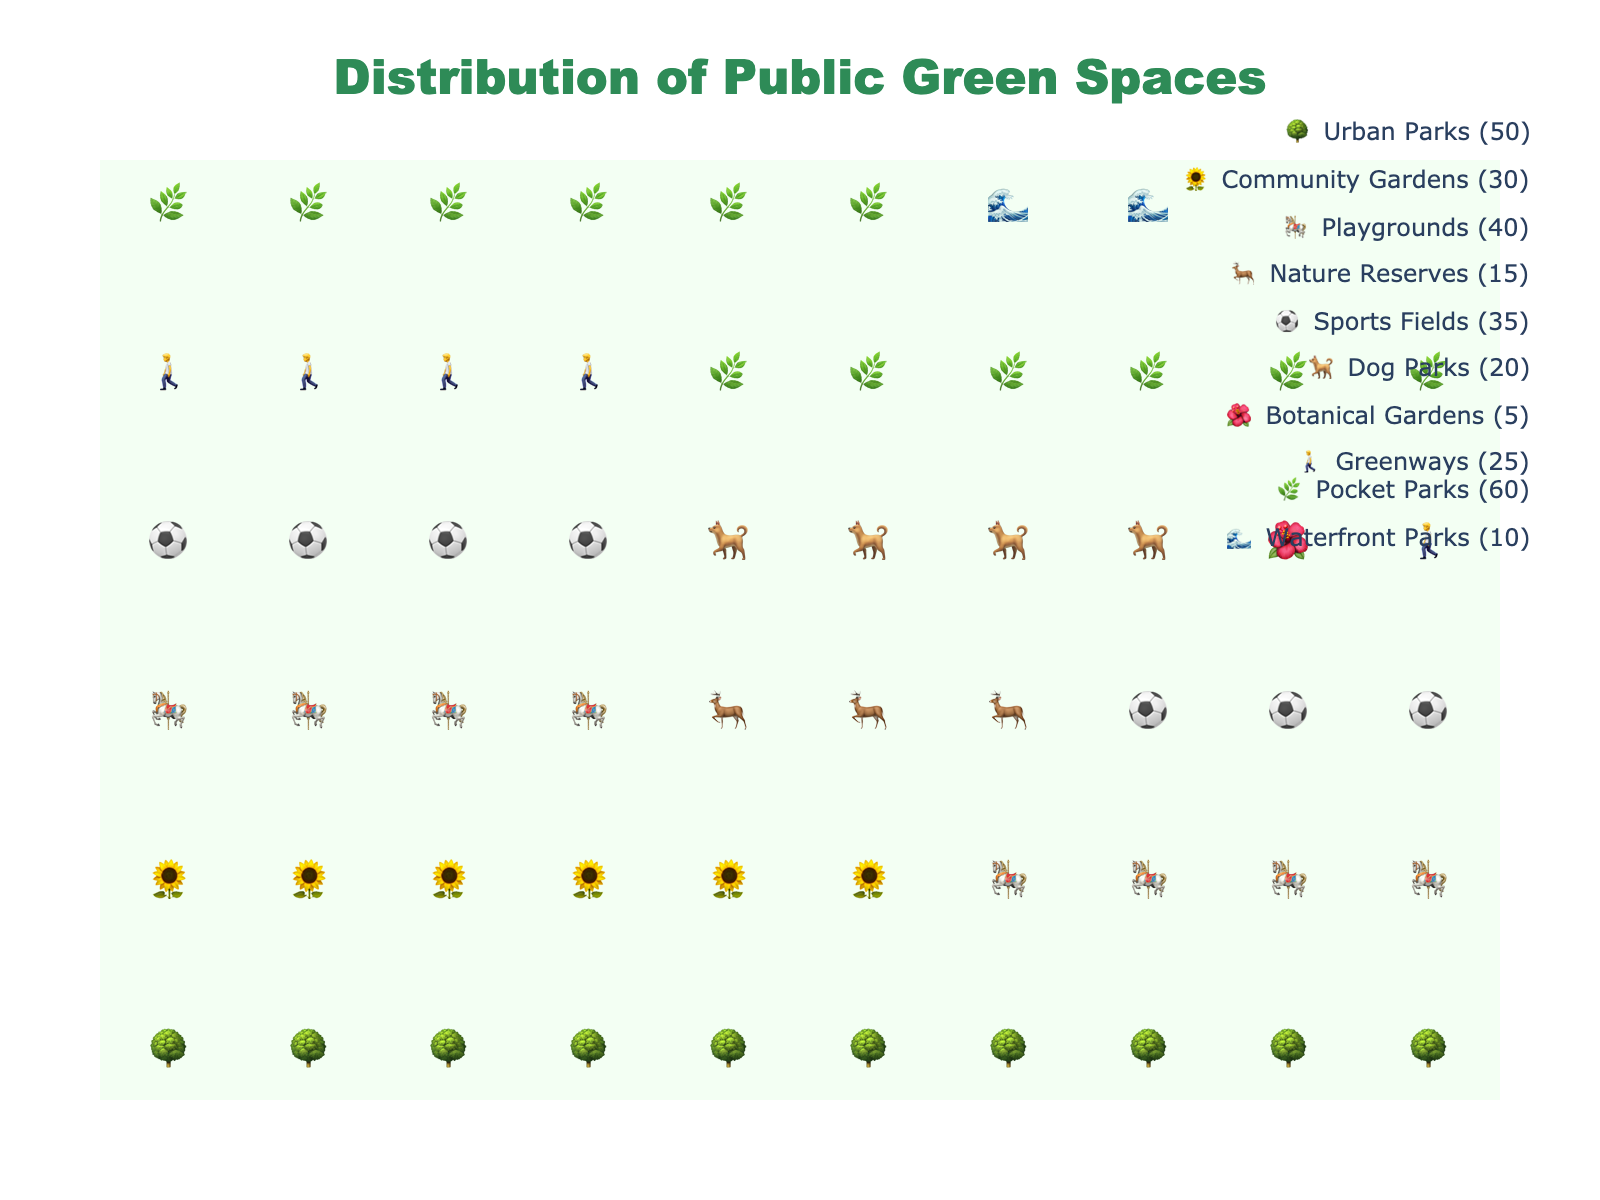Which type of green space is most predominant in urban areas based on the figure? By looking at the icons, Pocket Parks have the most icons displayed, indicating they have the highest count.
Answer: Pocket Parks What's the total count of Playgrounds and Dog Parks combined? According to the figure, Playgrounds have 40 icons and Dog Parks have 20 icons. Summing them up gives 40 + 20 = 60.
Answer: 60 How many more Urban Parks are there compared to Waterfront Parks? Urban Parks have 50 icons, and Waterfront Parks have 10 icons. The difference is 50 - 10 = 40.
Answer: 40 Which type of green space is the least represented in urban areas? Botanical Gardens have the fewest icons in the figure.
Answer: Botanical Gardens Are there more Community Gardens or Sports Fields? By looking at the icons, there are more Community Gardens (30) compared to Sports Fields (35).
Answer: Sports Fields What is the total number of all types of public green spaces shown in the figure? Sum all the counts: 50 (Urban Parks) + 30 (Community Gardens) + 40 (Playgrounds) + 15 (Nature Reserves) + 35 (Sports Fields) + 20 (Dog Parks) + 5 (Botanical Gardens) + 25 (Greenways) + 60 (Pocket Parks) + 10 (Waterfront Parks) = 290.
Answer: 290 Which types of green spaces have fewer than 25 icons? The types with fewer than 25 icons are Nature Reserves (15), Dog Parks (20), Botanical Gardens (5), and Waterfront Parks (10).
Answer: Nature Reserves, Dog Parks, Botanical Gardens, Waterfront Parks What percentage of the total public green spaces do the Sports Fields represent? First calculate the total number of spaces (290), then find the count of Sports Fields (35), and divide: 35 / 290 × 100 ≈ 12.07%.
Answer: Approximately 12.07% Compare the representation of Greenways and Community Gardens. Which one is greater, and by how much? Greenways have 25 icons whereas Community Gardens have 30 icons. Therefore, Community Gardens have 5 more icons than Greenways.
Answer: Community Gardens by 5 Considering Urban Parks, Community Gardens, and Playgrounds together, what fraction of the total does this group represent? Sum their counts: 50 (Urban Parks) + 30 (Community Gardens) + 40 (Playgrounds) = 120. The total count is 290. The fraction is 120/290, which simplifies to approximately 12/29.
Answer: Approximately 12/29 